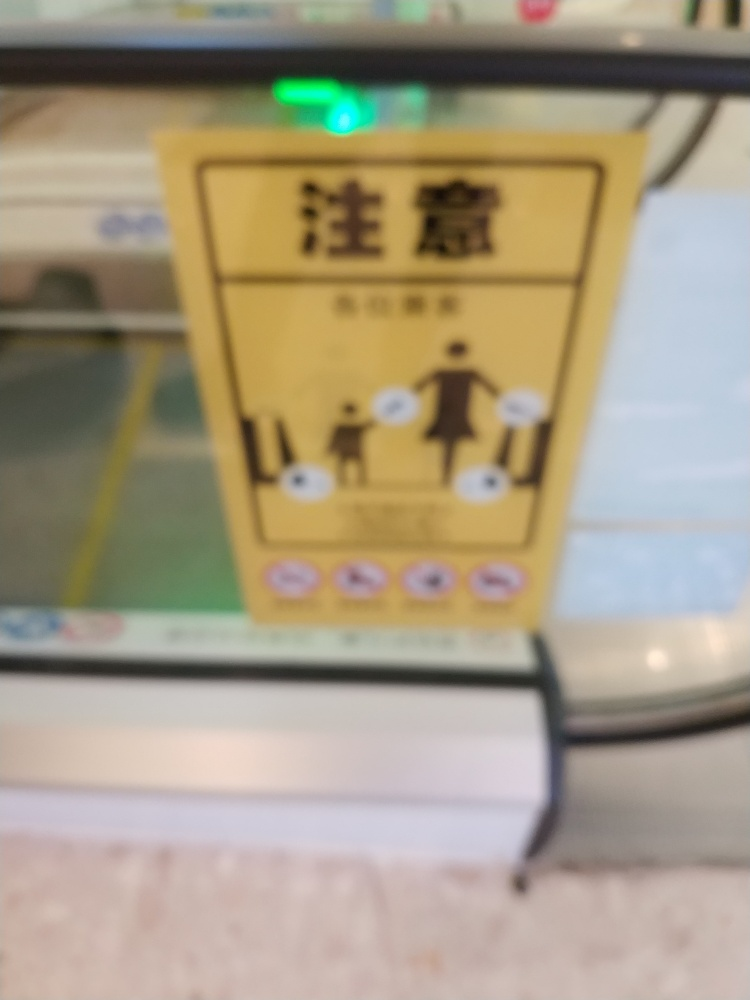What can you infer about the location of the image? It seems to be taken in an indoor setting, potentially in a public space like a station or mall, as indicated by the signage, tiled flooring, and the presence of a handrail, which are typical in such environments. Is there any cultural or geographical information that can be gleaned from the image? From the visible script on the signage, which appears to be East Asian, it might be inferred that the location is in a region where such characters are common, potentially in a country like China, Japan, or Korea. 